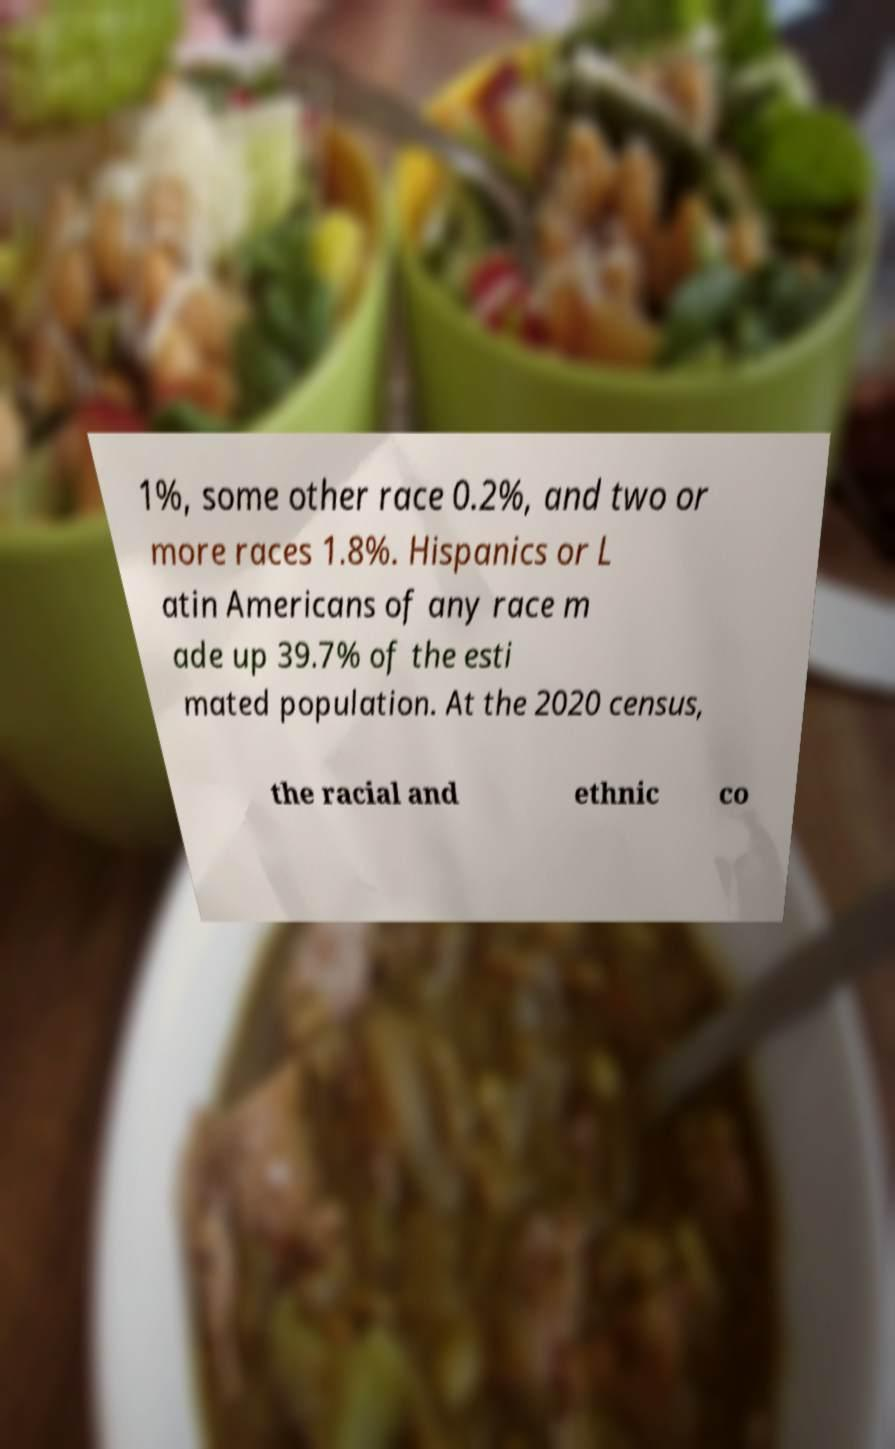I need the written content from this picture converted into text. Can you do that? 1%, some other race 0.2%, and two or more races 1.8%. Hispanics or L atin Americans of any race m ade up 39.7% of the esti mated population. At the 2020 census, the racial and ethnic co 